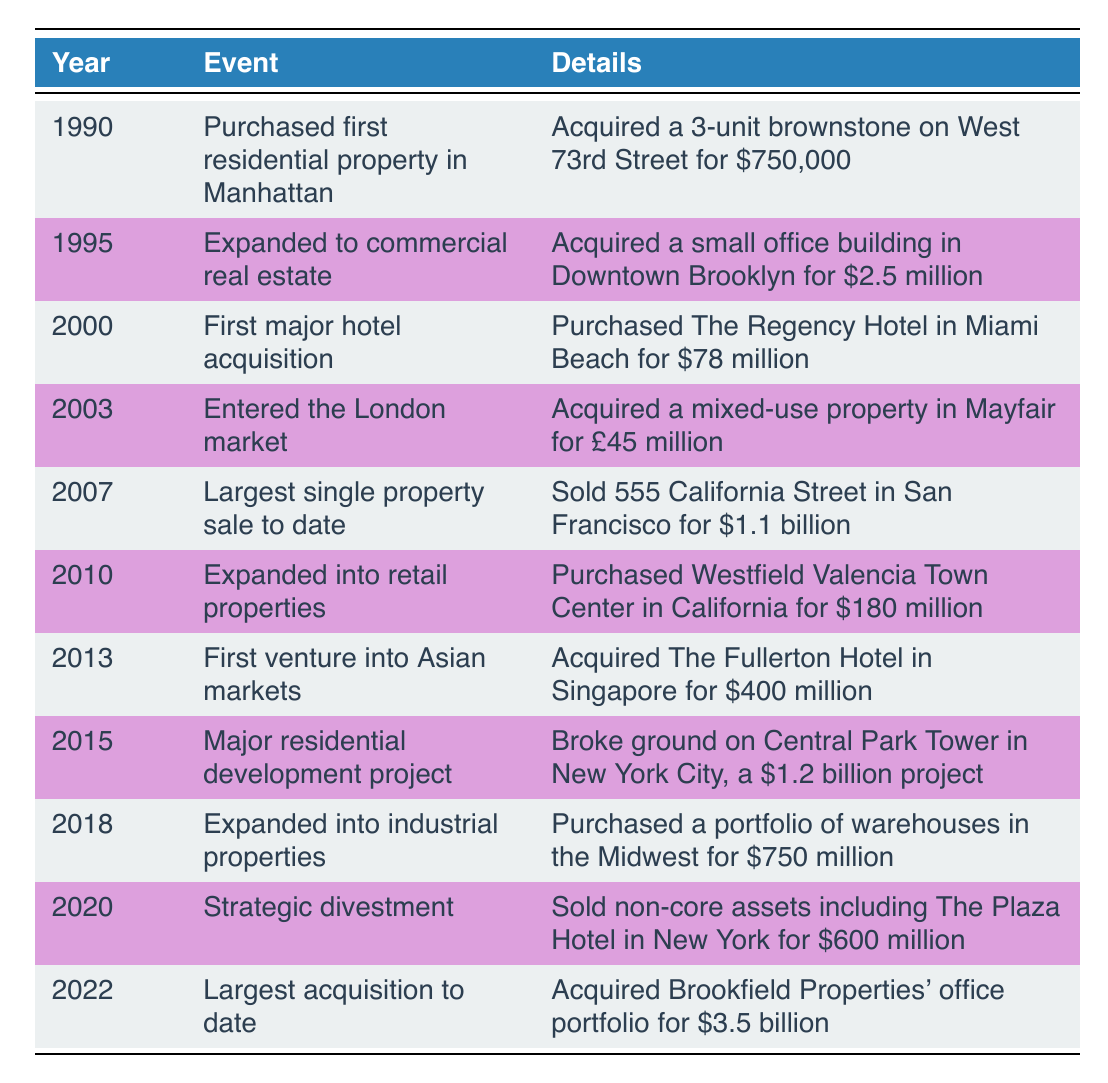What year did the first hotel acquisition happen? The table lists the event of the first major hotel acquisition in the year 2000.
Answer: 2000 How much was the investment in the first residential property? The table specifies the purchase of the first residential property in Manhattan for $750,000.
Answer: $750,000 What was the largest single property sale in the timeline? Referring to the table, the largest single property sale was 555 California Street in San Francisco for $1.1 billion in 2007.
Answer: $1.1 billion In which year was the largest acquisition to date made? The table shows that the largest acquisition to date was Brookfield Properties' office portfolio, which occurred in 2022.
Answer: 2022 True or False: The portfolio included any transaction in Asian markets prior to 2013. By examining the table, the first venture into Asian markets occurred in 2013, indicating there were no prior transactions in that region.
Answer: False What was the total amount spent on residential development projects listed in the timeline? The timeline includes two relevant entries: the first property in 1990 for $750,000 and the Central Park Tower in 2015 for $1.2 billion. Summing these gives a total of $750,000 + $1.2 billion = $1.20075 billion.
Answer: $1.20075 billion Did the portfolio include any retail property acquisitions before 2010? According to the table, the expansion into retail properties happened in 2010, indicating there were no retail property acquisitions made before that year.
Answer: No What percentage of the acquisition price for Brookfield Properties' office portfolio compares to the 2000 hotel acquisition? The acquisition price for Brookfield Properties was $3.5 billion, while the hotel acquisition in 2000 was $78 million. To find the percentage, first divide $78 million by $3.5 billion (0.078). Then multiply by 100 to get the percentage, which yields approximately 2.23%.
Answer: 2.23% In which two locations did property acquisitions happen in 2003? The table lists two acquisitions which include the mixed-use property in Mayfair, London in 2003. Thus, the focus was on the London market during that year, showing no additional locations reported alongside this event.
Answer: London 